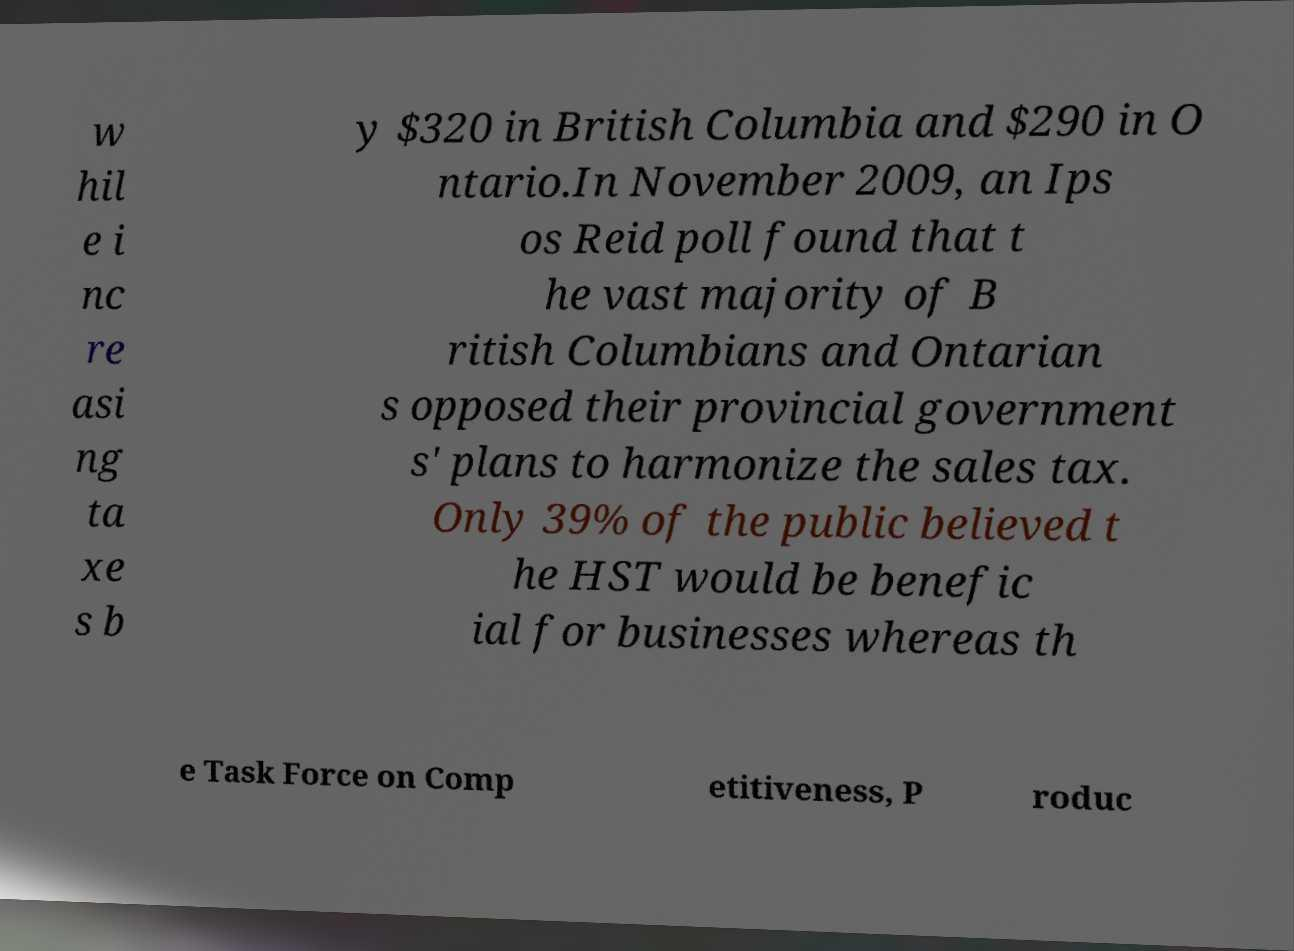For documentation purposes, I need the text within this image transcribed. Could you provide that? w hil e i nc re asi ng ta xe s b y $320 in British Columbia and $290 in O ntario.In November 2009, an Ips os Reid poll found that t he vast majority of B ritish Columbians and Ontarian s opposed their provincial government s' plans to harmonize the sales tax. Only 39% of the public believed t he HST would be benefic ial for businesses whereas th e Task Force on Comp etitiveness, P roduc 